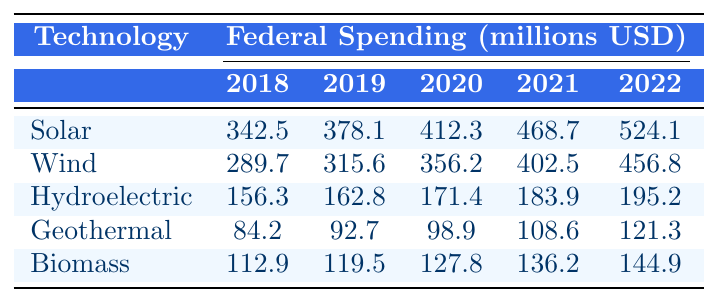What is the total federal spending on solar energy from 2018 to 2022? To find the total federal spending on solar energy, sum the values from each year: 342.5 + 378.1 + 412.3 + 468.7 + 524.1 = 2101.7 million USD.
Answer: 2101.7 million USD Which year had the highest spending for wind energy? Looking at the wind energy row, 2022 shows the highest value of 456.8 million USD compared to other years.
Answer: 2022 What is the difference in federal spending on hydroelectric energy between 2018 and 2022? Calculate the difference by subtracting the 2018 value (156.3 million USD) from the 2022 value (195.2 million USD): 195.2 - 156.3 = 38.9 million USD.
Answer: 38.9 million USD Is the federal spending on geothermal energy consistently increasing every year from 2018 to 2022? By reviewing the geothermal energy values, we see an increase from 84.2 to 121.3 million USD every year, confirming a consistent increase.
Answer: Yes What was the average federal spending on biomass from 2018 to 2022? To find the average, sum the biomass values, which are 112.9 + 119.5 + 127.8 + 136.2 + 144.9 = 641.3 million USD, then divide by 5 (the number of years): 641.3 / 5 = 128.26 million USD.
Answer: 128.26 million USD In which year did federal spending on wind energy show the largest increase compared to the previous year? To determine this, compare the year-on-year differences for wind energy: 2018 to 2019 is 25.9, 2019 to 2020 is 40.6, 2020 to 2021 is 46.3, and 2021 to 2022 is 54.3. The largest increase is from 2021 to 2022, which is 54.3 million USD.
Answer: 2021 to 2022 What was the total federal spending on renewable energy initiatives in 2021? To get the total for 2021, sum the values of all technologies for that year: 468.7 + 402.5 + 183.9 + 108.6 + 136.2 = 1300.0 million USD.
Answer: 1300.0 million USD Did federal spending on renewable energy initiatives exceed 150 million USD for hydroelectric energy in 2019? The value for hydroelectric in 2019 is 162.8 million USD, which is greater than 150 million USD.
Answer: Yes What was the trend in federal spending on renewable energy initiatives from 2018 to 2022? Analyzing the table shows that federal spending has increased for every technology type from 2018 to 2022, indicating a positive growth trend.
Answer: Increasing trend 